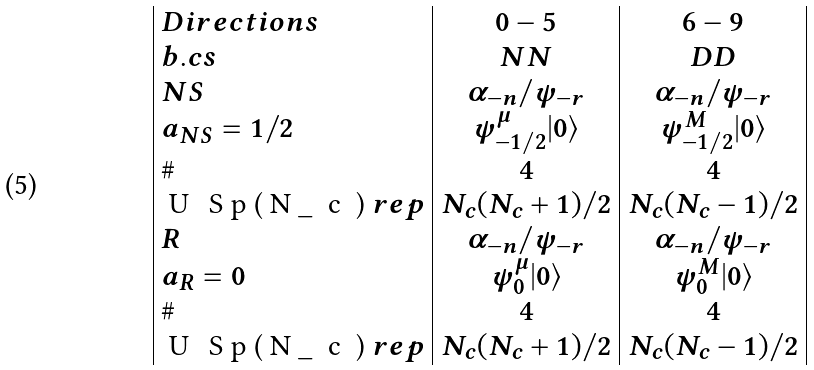<formula> <loc_0><loc_0><loc_500><loc_500>\begin{array} { | l | c | c | } D i r e c t i o n s & 0 - 5 & 6 - 9 \\ b . c s & N N & D D \\ N S & \alpha _ { - n } / \psi _ { - r } & \alpha _ { - n } / \psi _ { - r } \\ a _ { N S } = 1 / 2 & \psi _ { - 1 / 2 } ^ { \mu } | 0 \rangle & \psi _ { - 1 / 2 } ^ { M } | 0 \rangle \\ \# & 4 & 4 \\ $ U \, S p ( N _ { c } ) $ r e p & N _ { c } ( N _ { c } + 1 ) / 2 & N _ { c } ( N _ { c } - 1 ) / 2 \\ R & \alpha _ { - n } / \psi _ { - r } & \alpha _ { - n } / \psi _ { - r } \\ a _ { R } = 0 & \psi _ { 0 } ^ { \mu } | 0 \rangle & \psi _ { 0 } ^ { M } | 0 \rangle \\ \# & 4 & 4 \\ $ U \, S p ( N _ { c } ) $ r e p & N _ { c } ( N _ { c } + 1 ) / 2 & N _ { c } ( N _ { c } - 1 ) / 2 \\ \end{array}</formula> 